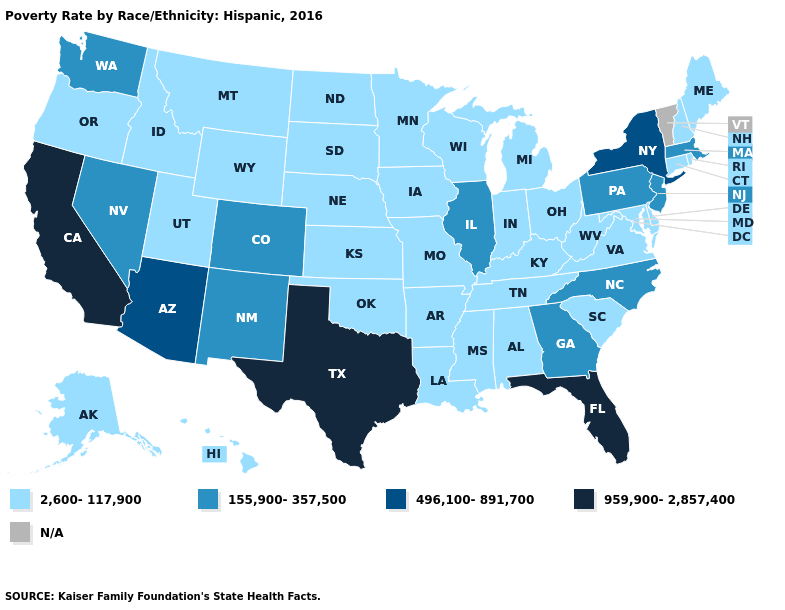Does the first symbol in the legend represent the smallest category?
Be succinct. Yes. What is the value of Maine?
Write a very short answer. 2,600-117,900. Which states hav the highest value in the Northeast?
Give a very brief answer. New York. What is the lowest value in the MidWest?
Quick response, please. 2,600-117,900. Which states have the lowest value in the West?
Short answer required. Alaska, Hawaii, Idaho, Montana, Oregon, Utah, Wyoming. What is the value of California?
Be succinct. 959,900-2,857,400. Which states hav the highest value in the MidWest?
Concise answer only. Illinois. Name the states that have a value in the range 496,100-891,700?
Write a very short answer. Arizona, New York. What is the value of Michigan?
Write a very short answer. 2,600-117,900. Which states hav the highest value in the MidWest?
Short answer required. Illinois. What is the highest value in the USA?
Short answer required. 959,900-2,857,400. What is the value of Texas?
Write a very short answer. 959,900-2,857,400. What is the value of Montana?
Answer briefly. 2,600-117,900. 